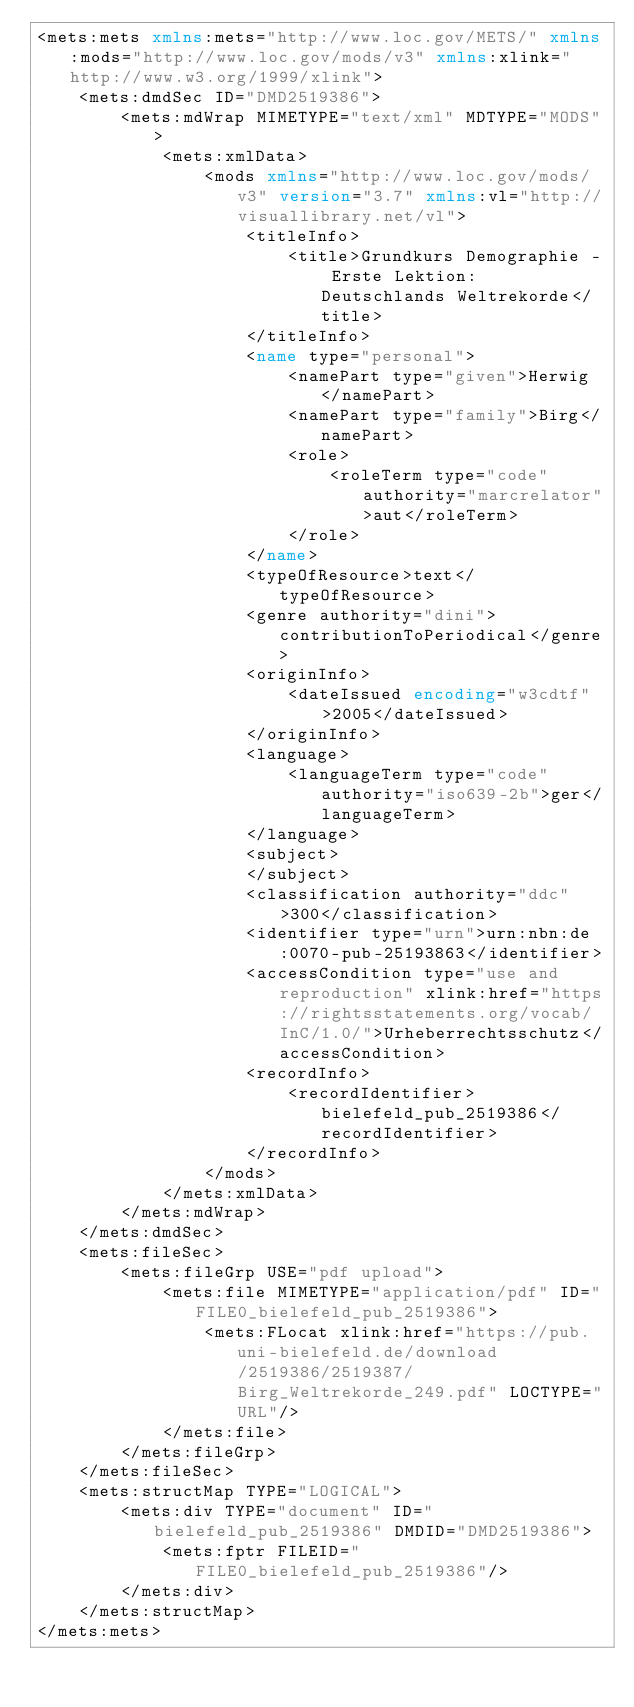<code> <loc_0><loc_0><loc_500><loc_500><_XML_><mets:mets xmlns:mets="http://www.loc.gov/METS/" xmlns:mods="http://www.loc.gov/mods/v3" xmlns:xlink="http://www.w3.org/1999/xlink">
    <mets:dmdSec ID="DMD2519386">
        <mets:mdWrap MIMETYPE="text/xml" MDTYPE="MODS">
            <mets:xmlData>
                <mods xmlns="http://www.loc.gov/mods/v3" version="3.7" xmlns:vl="http://visuallibrary.net/vl">
                    <titleInfo>
                        <title>Grundkurs Demographie - Erste Lektion: Deutschlands Weltrekorde</title>
                    </titleInfo>
                    <name type="personal">
                        <namePart type="given">Herwig</namePart>
                        <namePart type="family">Birg</namePart>
                        <role>
                            <roleTerm type="code" authority="marcrelator">aut</roleTerm>
                        </role>
                    </name>
                    <typeOfResource>text</typeOfResource>
                    <genre authority="dini">contributionToPeriodical</genre>
                    <originInfo>
                        <dateIssued encoding="w3cdtf">2005</dateIssued>
                    </originInfo>
                    <language>
                        <languageTerm type="code" authority="iso639-2b">ger</languageTerm>
                    </language>
                    <subject>
                    </subject>
                    <classification authority="ddc">300</classification>
                    <identifier type="urn">urn:nbn:de:0070-pub-25193863</identifier>
                    <accessCondition type="use and reproduction" xlink:href="https://rightsstatements.org/vocab/InC/1.0/">Urheberrechtsschutz</accessCondition>
                    <recordInfo>
                        <recordIdentifier>bielefeld_pub_2519386</recordIdentifier>
                    </recordInfo>
                </mods>
            </mets:xmlData>
        </mets:mdWrap>
    </mets:dmdSec>
    <mets:fileSec>
        <mets:fileGrp USE="pdf upload">
            <mets:file MIMETYPE="application/pdf" ID="FILE0_bielefeld_pub_2519386">
                <mets:FLocat xlink:href="https://pub.uni-bielefeld.de/download/2519386/2519387/Birg_Weltrekorde_249.pdf" LOCTYPE="URL"/>
            </mets:file>
        </mets:fileGrp>
    </mets:fileSec>
    <mets:structMap TYPE="LOGICAL">
        <mets:div TYPE="document" ID="bielefeld_pub_2519386" DMDID="DMD2519386">
            <mets:fptr FILEID="FILE0_bielefeld_pub_2519386"/>
        </mets:div>
    </mets:structMap>
</mets:mets>
</code> 